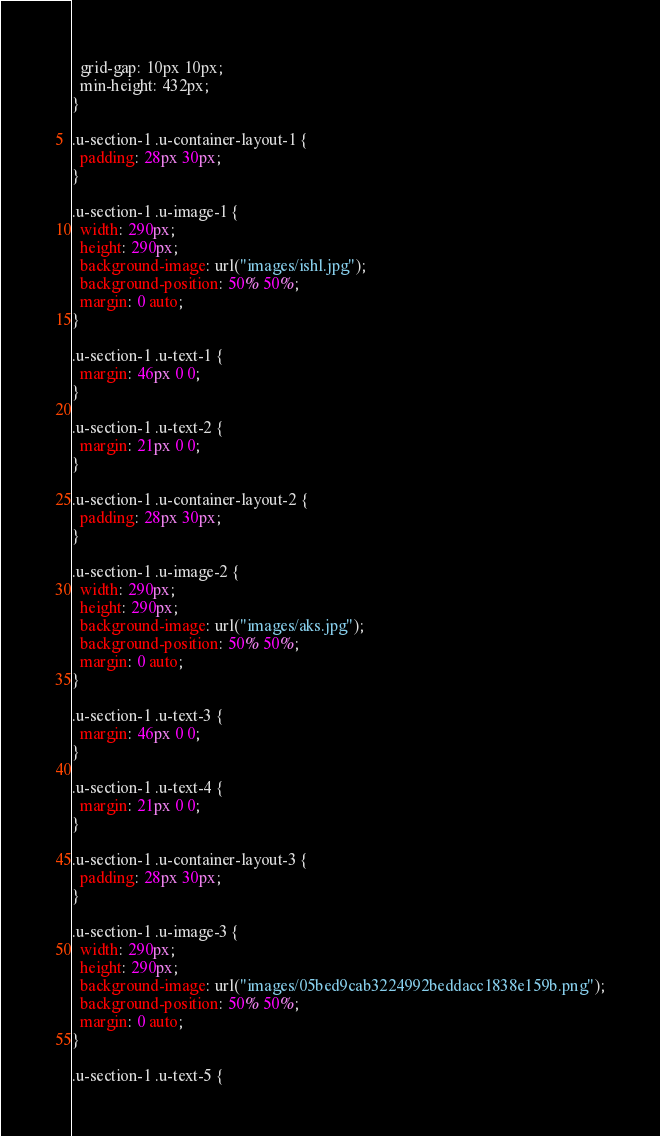<code> <loc_0><loc_0><loc_500><loc_500><_CSS_>  grid-gap: 10px 10px;
  min-height: 432px;
}

.u-section-1 .u-container-layout-1 {
  padding: 28px 30px;
}

.u-section-1 .u-image-1 {
  width: 290px;
  height: 290px;
  background-image: url("images/ishl.jpg");
  background-position: 50% 50%;
  margin: 0 auto;
}

.u-section-1 .u-text-1 {
  margin: 46px 0 0;
}

.u-section-1 .u-text-2 {
  margin: 21px 0 0;
}

.u-section-1 .u-container-layout-2 {
  padding: 28px 30px;
}

.u-section-1 .u-image-2 {
  width: 290px;
  height: 290px;
  background-image: url("images/aks.jpg");
  background-position: 50% 50%;
  margin: 0 auto;
}

.u-section-1 .u-text-3 {
  margin: 46px 0 0;
}

.u-section-1 .u-text-4 {
  margin: 21px 0 0;
}

.u-section-1 .u-container-layout-3 {
  padding: 28px 30px;
}

.u-section-1 .u-image-3 {
  width: 290px;
  height: 290px;
  background-image: url("images/05bed9cab3224992beddacc1838e159b.png");
  background-position: 50% 50%;
  margin: 0 auto;
}

.u-section-1 .u-text-5 {</code> 